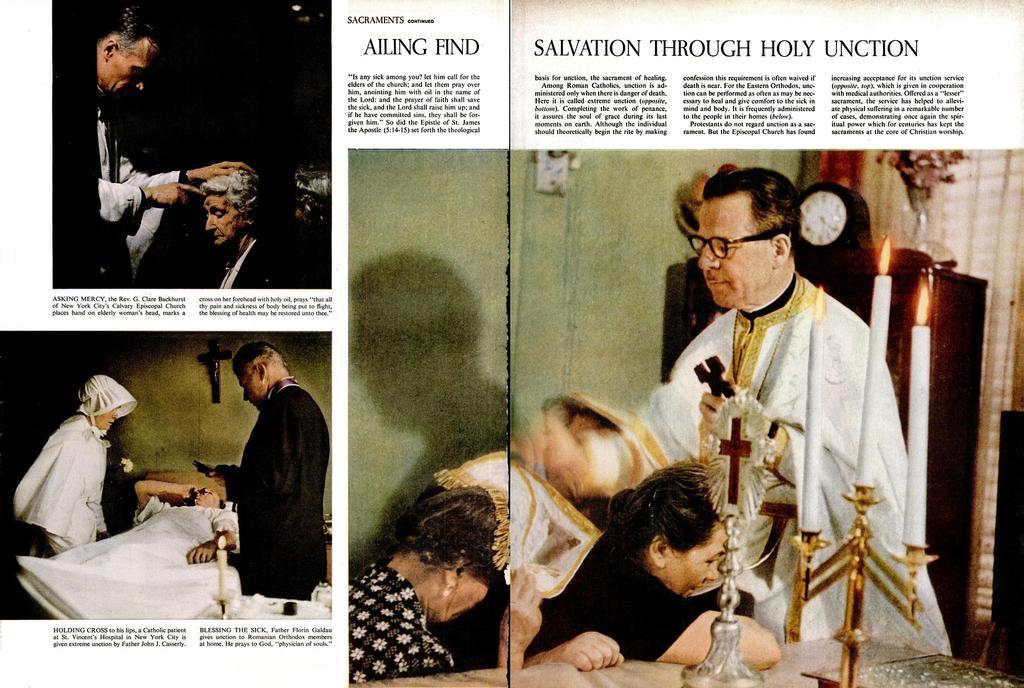Can you describe this image briefly? In this image we can see there is an article. In the middle there is a priest who is blessing the people who are in front of him. At the bottom there is a table on which there is a candle stand. In the background there is a cupboard on which there is a clock and a flower vase. On the right side there is a curtain. At the top there is some text. On the left side bottom there is a man in the middle who is sleeping on the bed. There are two persons beside him. 